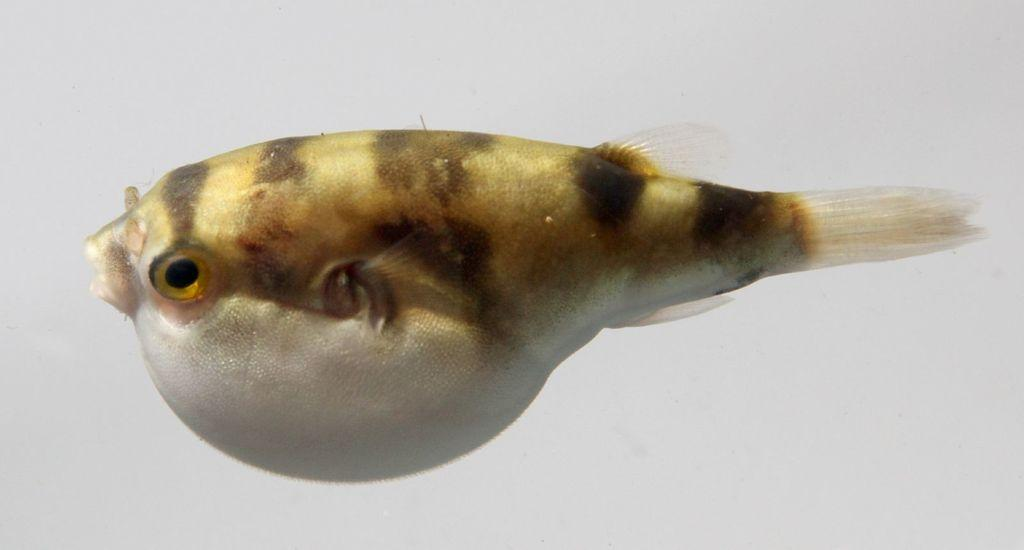What is the main subject of the image? The main subject of the image is a fish. Can you describe the location of the fish in the image? The fish is in the middle of the image. What type of board game is the father playing with the fairies in the image? There is no father, fairies, or board game present in the image; it only features a fish in the middle. 